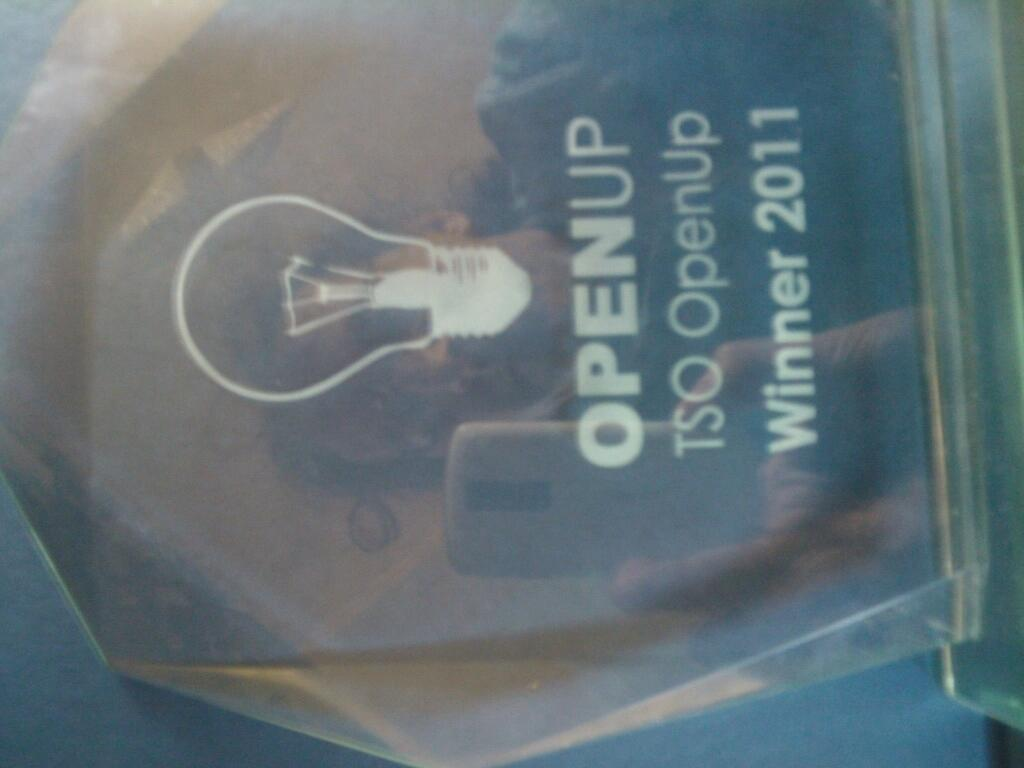<image>
Write a terse but informative summary of the picture. An OPENUP award for the 2011 winner has a picture of a lightbulb etched on it. 